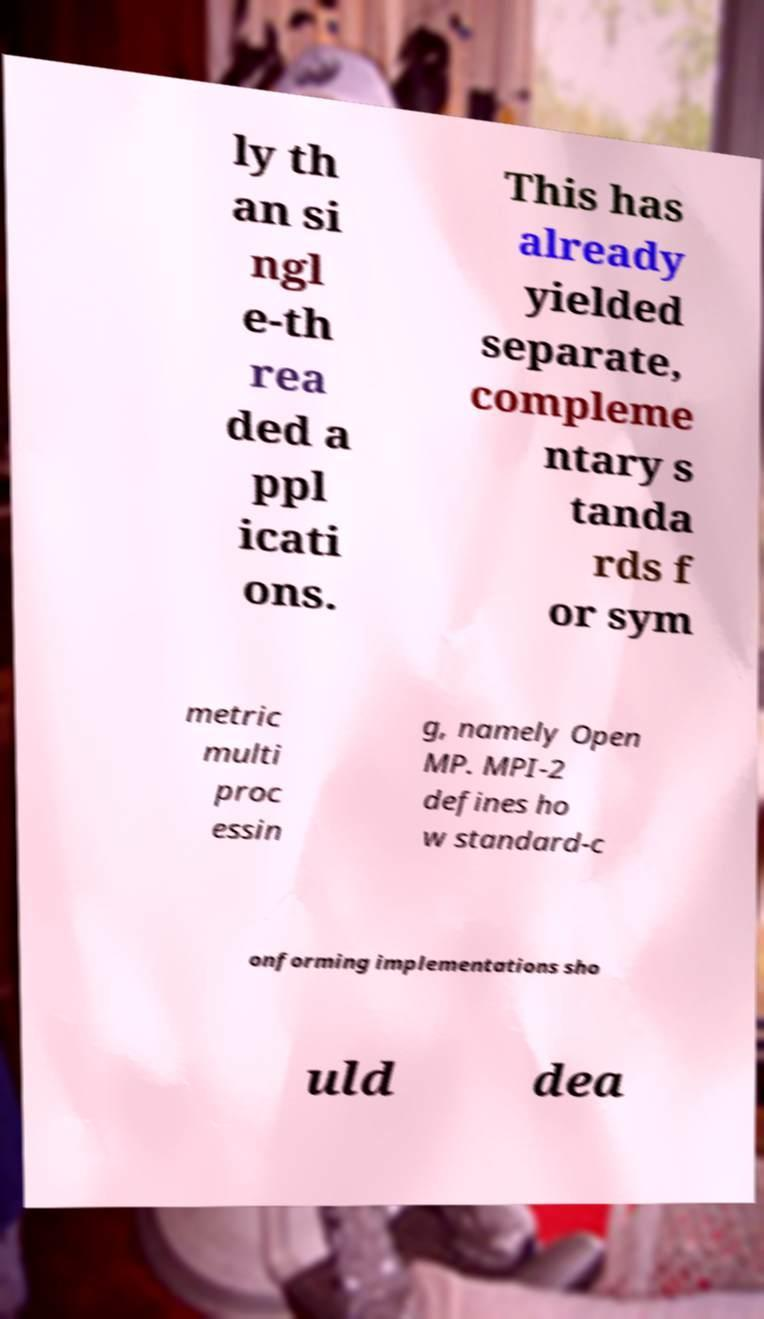Could you assist in decoding the text presented in this image and type it out clearly? ly th an si ngl e-th rea ded a ppl icati ons. This has already yielded separate, compleme ntary s tanda rds f or sym metric multi proc essin g, namely Open MP. MPI-2 defines ho w standard-c onforming implementations sho uld dea 